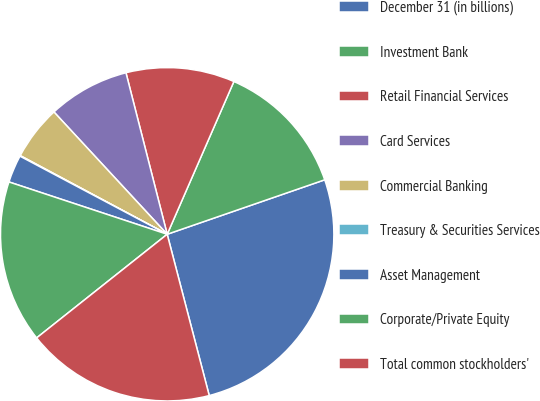<chart> <loc_0><loc_0><loc_500><loc_500><pie_chart><fcel>December 31 (in billions)<fcel>Investment Bank<fcel>Retail Financial Services<fcel>Card Services<fcel>Commercial Banking<fcel>Treasury & Securities Services<fcel>Asset Management<fcel>Corporate/Private Equity<fcel>Total common stockholders'<nl><fcel>26.24%<fcel>13.15%<fcel>10.53%<fcel>7.91%<fcel>5.29%<fcel>0.06%<fcel>2.68%<fcel>15.76%<fcel>18.38%<nl></chart> 